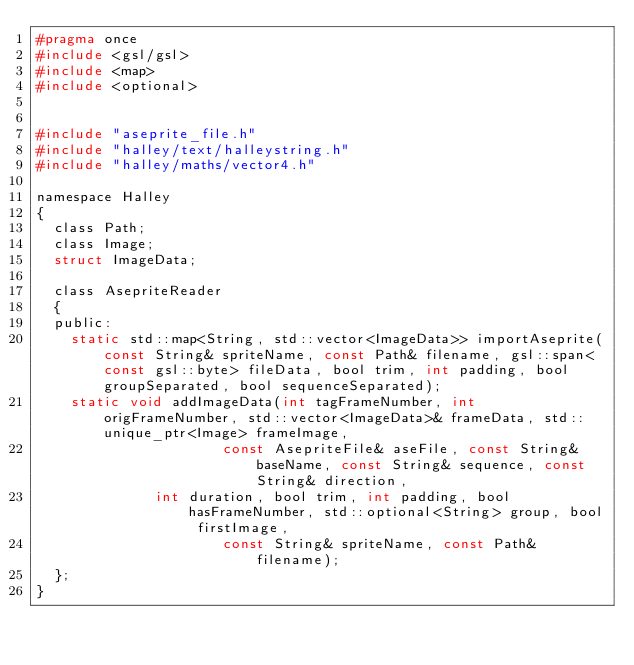Convert code to text. <code><loc_0><loc_0><loc_500><loc_500><_C_>#pragma once
#include <gsl/gsl>
#include <map>
#include <optional>


#include "aseprite_file.h"
#include "halley/text/halleystring.h"
#include "halley/maths/vector4.h"

namespace Halley
{
	class Path;
	class Image;
	struct ImageData;

	class AsepriteReader
	{
	public:
		static std::map<String, std::vector<ImageData>> importAseprite(const String& spriteName, const Path& filename, gsl::span<const gsl::byte> fileData, bool trim, int padding, bool groupSeparated, bool sequenceSeparated);
		static void addImageData(int tagFrameNumber, int origFrameNumber, std::vector<ImageData>& frameData, std::unique_ptr<Image> frameImage,
		                  const AsepriteFile& aseFile, const String& baseName, const String& sequence, const String& direction,
						  int duration, bool trim, int padding, bool hasFrameNumber, std::optional<String> group, bool firstImage,
		                  const String& spriteName, const Path& filename);
	};
}
</code> 